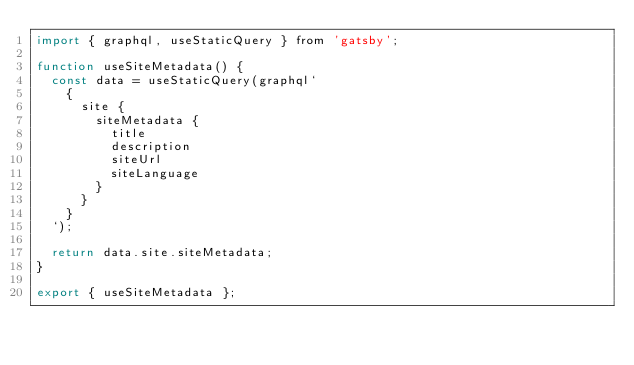<code> <loc_0><loc_0><loc_500><loc_500><_JavaScript_>import { graphql, useStaticQuery } from 'gatsby';

function useSiteMetadata() {
  const data = useStaticQuery(graphql`
    {
      site {
        siteMetadata {
          title
          description
          siteUrl
          siteLanguage
        }
      }
    }
  `);

  return data.site.siteMetadata;
}

export { useSiteMetadata };
</code> 